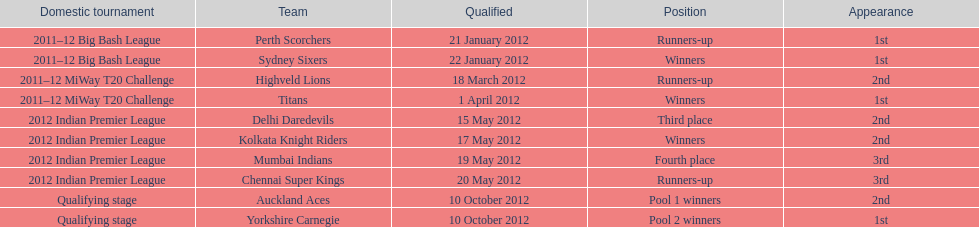What is the total number of teams? 10. 